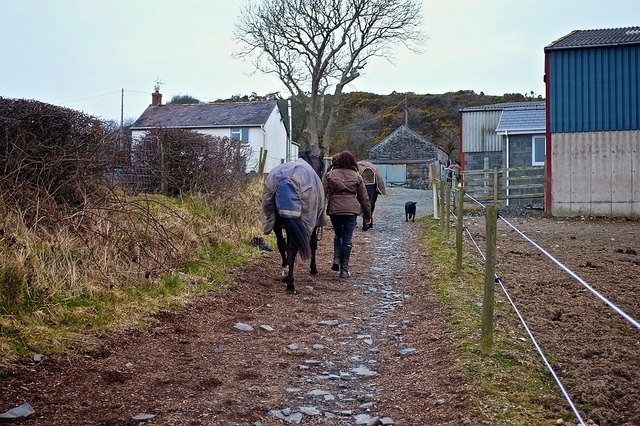Describe the objects in this image and their specific colors. I can see horse in lightblue, black, and gray tones, people in lightblue, black, and gray tones, horse in lightblue, black, gray, and darkgray tones, and dog in lightblue, black, gray, navy, and darkblue tones in this image. 